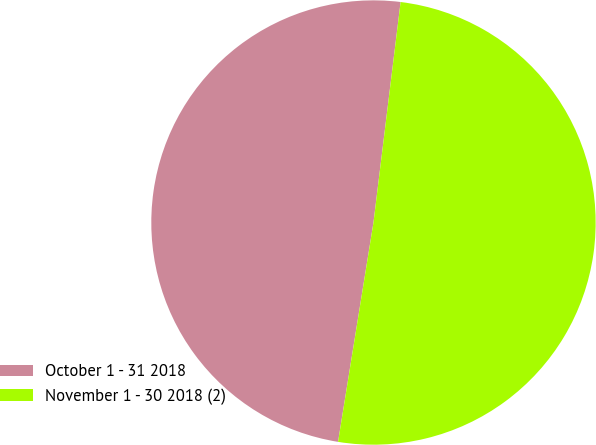Convert chart to OTSL. <chart><loc_0><loc_0><loc_500><loc_500><pie_chart><fcel>October 1 - 31 2018<fcel>November 1 - 30 2018 (2)<nl><fcel>49.4%<fcel>50.6%<nl></chart> 